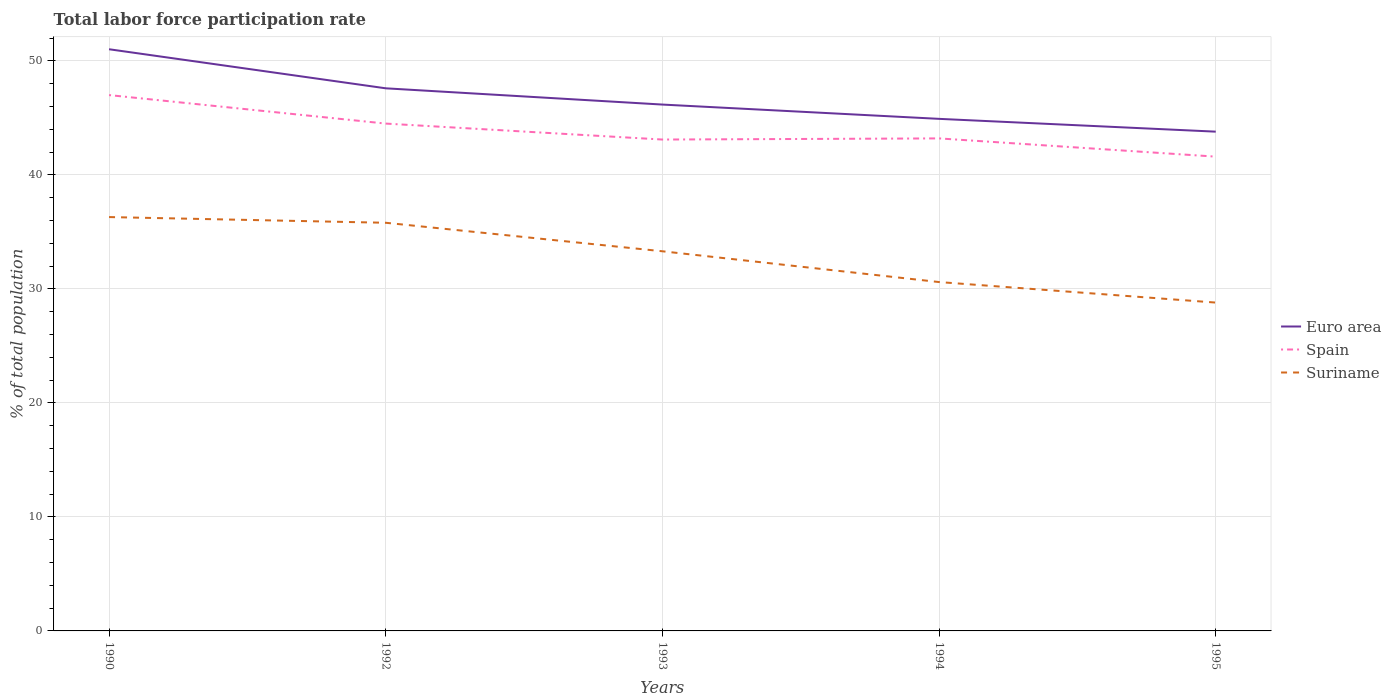Does the line corresponding to Euro area intersect with the line corresponding to Suriname?
Keep it short and to the point. No. Is the number of lines equal to the number of legend labels?
Your answer should be very brief. Yes. Across all years, what is the maximum total labor force participation rate in Suriname?
Make the answer very short. 28.8. In which year was the total labor force participation rate in Spain maximum?
Give a very brief answer. 1995. What is the total total labor force participation rate in Suriname in the graph?
Your answer should be very brief. 2.5. What is the difference between the highest and the second highest total labor force participation rate in Euro area?
Offer a very short reply. 7.23. What is the difference between the highest and the lowest total labor force participation rate in Spain?
Your answer should be very brief. 2. How many lines are there?
Make the answer very short. 3. How many years are there in the graph?
Your answer should be very brief. 5. What is the difference between two consecutive major ticks on the Y-axis?
Give a very brief answer. 10. Are the values on the major ticks of Y-axis written in scientific E-notation?
Offer a terse response. No. Does the graph contain any zero values?
Give a very brief answer. No. How many legend labels are there?
Provide a succinct answer. 3. What is the title of the graph?
Provide a short and direct response. Total labor force participation rate. Does "Iraq" appear as one of the legend labels in the graph?
Your answer should be compact. No. What is the label or title of the Y-axis?
Offer a terse response. % of total population. What is the % of total population of Euro area in 1990?
Give a very brief answer. 51.02. What is the % of total population of Suriname in 1990?
Offer a very short reply. 36.3. What is the % of total population of Euro area in 1992?
Ensure brevity in your answer.  47.59. What is the % of total population in Spain in 1992?
Your answer should be very brief. 44.5. What is the % of total population of Suriname in 1992?
Keep it short and to the point. 35.8. What is the % of total population of Euro area in 1993?
Ensure brevity in your answer.  46.17. What is the % of total population of Spain in 1993?
Your answer should be very brief. 43.1. What is the % of total population of Suriname in 1993?
Your answer should be compact. 33.3. What is the % of total population of Euro area in 1994?
Ensure brevity in your answer.  44.91. What is the % of total population in Spain in 1994?
Give a very brief answer. 43.2. What is the % of total population of Suriname in 1994?
Your answer should be very brief. 30.6. What is the % of total population of Euro area in 1995?
Your answer should be very brief. 43.79. What is the % of total population of Spain in 1995?
Provide a succinct answer. 41.6. What is the % of total population in Suriname in 1995?
Provide a succinct answer. 28.8. Across all years, what is the maximum % of total population in Euro area?
Ensure brevity in your answer.  51.02. Across all years, what is the maximum % of total population of Spain?
Ensure brevity in your answer.  47. Across all years, what is the maximum % of total population of Suriname?
Offer a terse response. 36.3. Across all years, what is the minimum % of total population in Euro area?
Ensure brevity in your answer.  43.79. Across all years, what is the minimum % of total population of Spain?
Your answer should be compact. 41.6. Across all years, what is the minimum % of total population in Suriname?
Ensure brevity in your answer.  28.8. What is the total % of total population in Euro area in the graph?
Give a very brief answer. 233.49. What is the total % of total population of Spain in the graph?
Give a very brief answer. 219.4. What is the total % of total population of Suriname in the graph?
Provide a succinct answer. 164.8. What is the difference between the % of total population of Euro area in 1990 and that in 1992?
Your answer should be very brief. 3.43. What is the difference between the % of total population in Spain in 1990 and that in 1992?
Your response must be concise. 2.5. What is the difference between the % of total population of Euro area in 1990 and that in 1993?
Your response must be concise. 4.85. What is the difference between the % of total population in Spain in 1990 and that in 1993?
Provide a short and direct response. 3.9. What is the difference between the % of total population of Suriname in 1990 and that in 1993?
Provide a succinct answer. 3. What is the difference between the % of total population of Euro area in 1990 and that in 1994?
Ensure brevity in your answer.  6.11. What is the difference between the % of total population in Spain in 1990 and that in 1994?
Your answer should be compact. 3.8. What is the difference between the % of total population in Suriname in 1990 and that in 1994?
Your response must be concise. 5.7. What is the difference between the % of total population in Euro area in 1990 and that in 1995?
Provide a succinct answer. 7.23. What is the difference between the % of total population in Spain in 1990 and that in 1995?
Your answer should be very brief. 5.4. What is the difference between the % of total population in Euro area in 1992 and that in 1993?
Your answer should be compact. 1.43. What is the difference between the % of total population of Suriname in 1992 and that in 1993?
Give a very brief answer. 2.5. What is the difference between the % of total population of Euro area in 1992 and that in 1994?
Offer a very short reply. 2.68. What is the difference between the % of total population in Euro area in 1992 and that in 1995?
Provide a succinct answer. 3.8. What is the difference between the % of total population in Euro area in 1993 and that in 1994?
Offer a terse response. 1.25. What is the difference between the % of total population in Spain in 1993 and that in 1994?
Offer a very short reply. -0.1. What is the difference between the % of total population of Euro area in 1993 and that in 1995?
Make the answer very short. 2.38. What is the difference between the % of total population of Euro area in 1994 and that in 1995?
Offer a very short reply. 1.12. What is the difference between the % of total population in Spain in 1994 and that in 1995?
Give a very brief answer. 1.6. What is the difference between the % of total population in Euro area in 1990 and the % of total population in Spain in 1992?
Offer a terse response. 6.52. What is the difference between the % of total population in Euro area in 1990 and the % of total population in Suriname in 1992?
Keep it short and to the point. 15.22. What is the difference between the % of total population in Spain in 1990 and the % of total population in Suriname in 1992?
Keep it short and to the point. 11.2. What is the difference between the % of total population of Euro area in 1990 and the % of total population of Spain in 1993?
Provide a succinct answer. 7.92. What is the difference between the % of total population in Euro area in 1990 and the % of total population in Suriname in 1993?
Give a very brief answer. 17.72. What is the difference between the % of total population of Euro area in 1990 and the % of total population of Spain in 1994?
Give a very brief answer. 7.82. What is the difference between the % of total population of Euro area in 1990 and the % of total population of Suriname in 1994?
Offer a very short reply. 20.42. What is the difference between the % of total population of Spain in 1990 and the % of total population of Suriname in 1994?
Give a very brief answer. 16.4. What is the difference between the % of total population of Euro area in 1990 and the % of total population of Spain in 1995?
Give a very brief answer. 9.42. What is the difference between the % of total population of Euro area in 1990 and the % of total population of Suriname in 1995?
Your answer should be compact. 22.22. What is the difference between the % of total population in Euro area in 1992 and the % of total population in Spain in 1993?
Make the answer very short. 4.49. What is the difference between the % of total population of Euro area in 1992 and the % of total population of Suriname in 1993?
Your answer should be compact. 14.29. What is the difference between the % of total population in Euro area in 1992 and the % of total population in Spain in 1994?
Your answer should be compact. 4.39. What is the difference between the % of total population of Euro area in 1992 and the % of total population of Suriname in 1994?
Offer a terse response. 16.99. What is the difference between the % of total population of Euro area in 1992 and the % of total population of Spain in 1995?
Keep it short and to the point. 5.99. What is the difference between the % of total population in Euro area in 1992 and the % of total population in Suriname in 1995?
Your answer should be very brief. 18.79. What is the difference between the % of total population in Spain in 1992 and the % of total population in Suriname in 1995?
Your answer should be compact. 15.7. What is the difference between the % of total population in Euro area in 1993 and the % of total population in Spain in 1994?
Provide a succinct answer. 2.97. What is the difference between the % of total population of Euro area in 1993 and the % of total population of Suriname in 1994?
Give a very brief answer. 15.57. What is the difference between the % of total population in Spain in 1993 and the % of total population in Suriname in 1994?
Ensure brevity in your answer.  12.5. What is the difference between the % of total population of Euro area in 1993 and the % of total population of Spain in 1995?
Give a very brief answer. 4.57. What is the difference between the % of total population of Euro area in 1993 and the % of total population of Suriname in 1995?
Offer a very short reply. 17.37. What is the difference between the % of total population of Euro area in 1994 and the % of total population of Spain in 1995?
Offer a very short reply. 3.31. What is the difference between the % of total population in Euro area in 1994 and the % of total population in Suriname in 1995?
Your answer should be compact. 16.11. What is the difference between the % of total population in Spain in 1994 and the % of total population in Suriname in 1995?
Make the answer very short. 14.4. What is the average % of total population in Euro area per year?
Offer a very short reply. 46.7. What is the average % of total population in Spain per year?
Offer a very short reply. 43.88. What is the average % of total population in Suriname per year?
Your answer should be very brief. 32.96. In the year 1990, what is the difference between the % of total population of Euro area and % of total population of Spain?
Provide a short and direct response. 4.02. In the year 1990, what is the difference between the % of total population in Euro area and % of total population in Suriname?
Your answer should be very brief. 14.72. In the year 1992, what is the difference between the % of total population of Euro area and % of total population of Spain?
Keep it short and to the point. 3.09. In the year 1992, what is the difference between the % of total population of Euro area and % of total population of Suriname?
Offer a terse response. 11.79. In the year 1993, what is the difference between the % of total population in Euro area and % of total population in Spain?
Make the answer very short. 3.07. In the year 1993, what is the difference between the % of total population in Euro area and % of total population in Suriname?
Your answer should be compact. 12.87. In the year 1994, what is the difference between the % of total population of Euro area and % of total population of Spain?
Make the answer very short. 1.71. In the year 1994, what is the difference between the % of total population of Euro area and % of total population of Suriname?
Your answer should be compact. 14.31. In the year 1995, what is the difference between the % of total population of Euro area and % of total population of Spain?
Offer a very short reply. 2.19. In the year 1995, what is the difference between the % of total population of Euro area and % of total population of Suriname?
Give a very brief answer. 14.99. What is the ratio of the % of total population of Euro area in 1990 to that in 1992?
Your answer should be compact. 1.07. What is the ratio of the % of total population of Spain in 1990 to that in 1992?
Give a very brief answer. 1.06. What is the ratio of the % of total population of Euro area in 1990 to that in 1993?
Ensure brevity in your answer.  1.11. What is the ratio of the % of total population of Spain in 1990 to that in 1993?
Offer a terse response. 1.09. What is the ratio of the % of total population of Suriname in 1990 to that in 1993?
Your answer should be very brief. 1.09. What is the ratio of the % of total population of Euro area in 1990 to that in 1994?
Offer a terse response. 1.14. What is the ratio of the % of total population in Spain in 1990 to that in 1994?
Your response must be concise. 1.09. What is the ratio of the % of total population of Suriname in 1990 to that in 1994?
Offer a very short reply. 1.19. What is the ratio of the % of total population in Euro area in 1990 to that in 1995?
Ensure brevity in your answer.  1.17. What is the ratio of the % of total population of Spain in 1990 to that in 1995?
Ensure brevity in your answer.  1.13. What is the ratio of the % of total population in Suriname in 1990 to that in 1995?
Provide a succinct answer. 1.26. What is the ratio of the % of total population of Euro area in 1992 to that in 1993?
Keep it short and to the point. 1.03. What is the ratio of the % of total population in Spain in 1992 to that in 1993?
Provide a short and direct response. 1.03. What is the ratio of the % of total population in Suriname in 1992 to that in 1993?
Make the answer very short. 1.08. What is the ratio of the % of total population of Euro area in 1992 to that in 1994?
Ensure brevity in your answer.  1.06. What is the ratio of the % of total population of Spain in 1992 to that in 1994?
Make the answer very short. 1.03. What is the ratio of the % of total population of Suriname in 1992 to that in 1994?
Offer a terse response. 1.17. What is the ratio of the % of total population of Euro area in 1992 to that in 1995?
Give a very brief answer. 1.09. What is the ratio of the % of total population in Spain in 1992 to that in 1995?
Ensure brevity in your answer.  1.07. What is the ratio of the % of total population of Suriname in 1992 to that in 1995?
Keep it short and to the point. 1.24. What is the ratio of the % of total population in Euro area in 1993 to that in 1994?
Provide a succinct answer. 1.03. What is the ratio of the % of total population of Suriname in 1993 to that in 1994?
Offer a terse response. 1.09. What is the ratio of the % of total population of Euro area in 1993 to that in 1995?
Offer a very short reply. 1.05. What is the ratio of the % of total population of Spain in 1993 to that in 1995?
Make the answer very short. 1.04. What is the ratio of the % of total population of Suriname in 1993 to that in 1995?
Your response must be concise. 1.16. What is the ratio of the % of total population of Euro area in 1994 to that in 1995?
Your answer should be very brief. 1.03. What is the ratio of the % of total population of Spain in 1994 to that in 1995?
Make the answer very short. 1.04. What is the difference between the highest and the second highest % of total population in Euro area?
Provide a short and direct response. 3.43. What is the difference between the highest and the second highest % of total population in Suriname?
Your response must be concise. 0.5. What is the difference between the highest and the lowest % of total population of Euro area?
Keep it short and to the point. 7.23. What is the difference between the highest and the lowest % of total population in Spain?
Give a very brief answer. 5.4. What is the difference between the highest and the lowest % of total population of Suriname?
Provide a short and direct response. 7.5. 